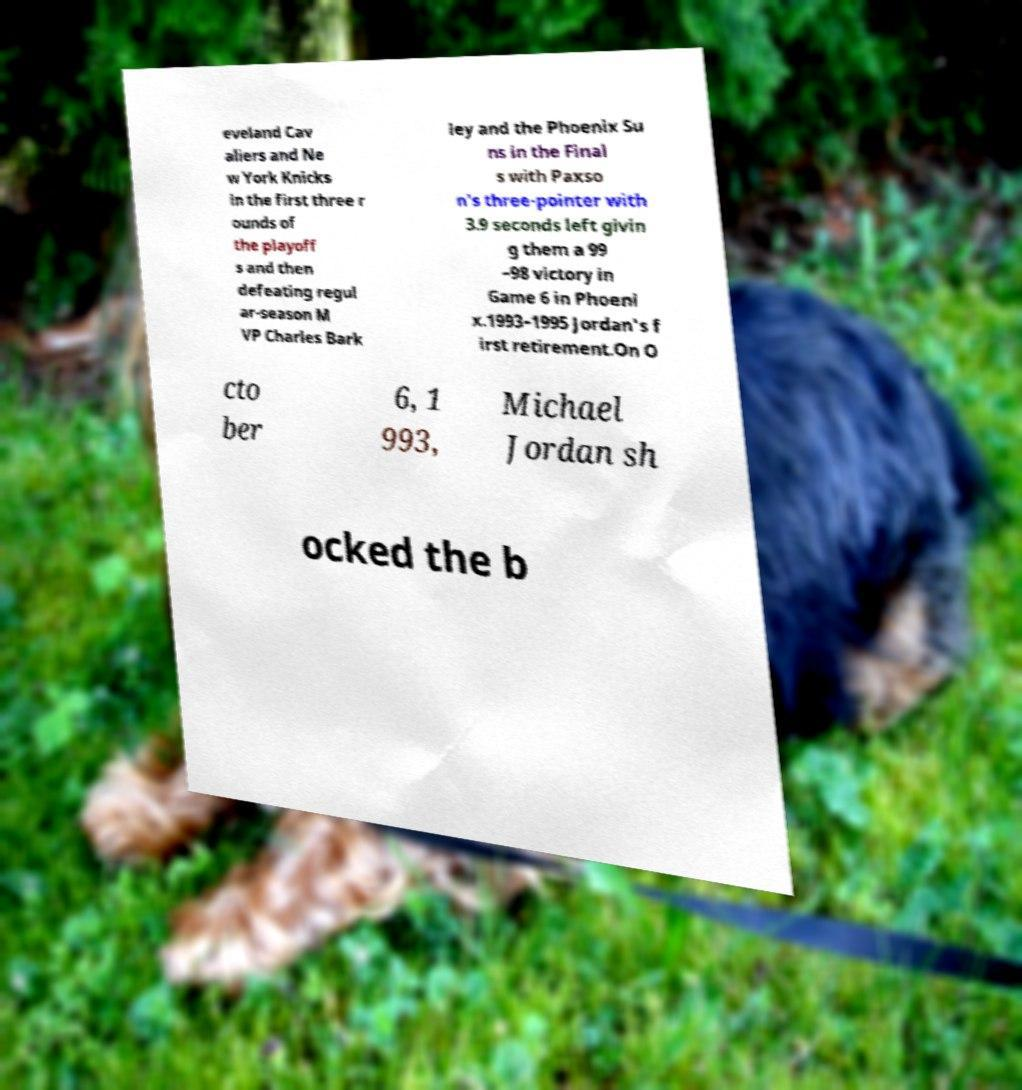For documentation purposes, I need the text within this image transcribed. Could you provide that? eveland Cav aliers and Ne w York Knicks in the first three r ounds of the playoff s and then defeating regul ar-season M VP Charles Bark ley and the Phoenix Su ns in the Final s with Paxso n's three-pointer with 3.9 seconds left givin g them a 99 –98 victory in Game 6 in Phoeni x.1993–1995 Jordan's f irst retirement.On O cto ber 6, 1 993, Michael Jordan sh ocked the b 